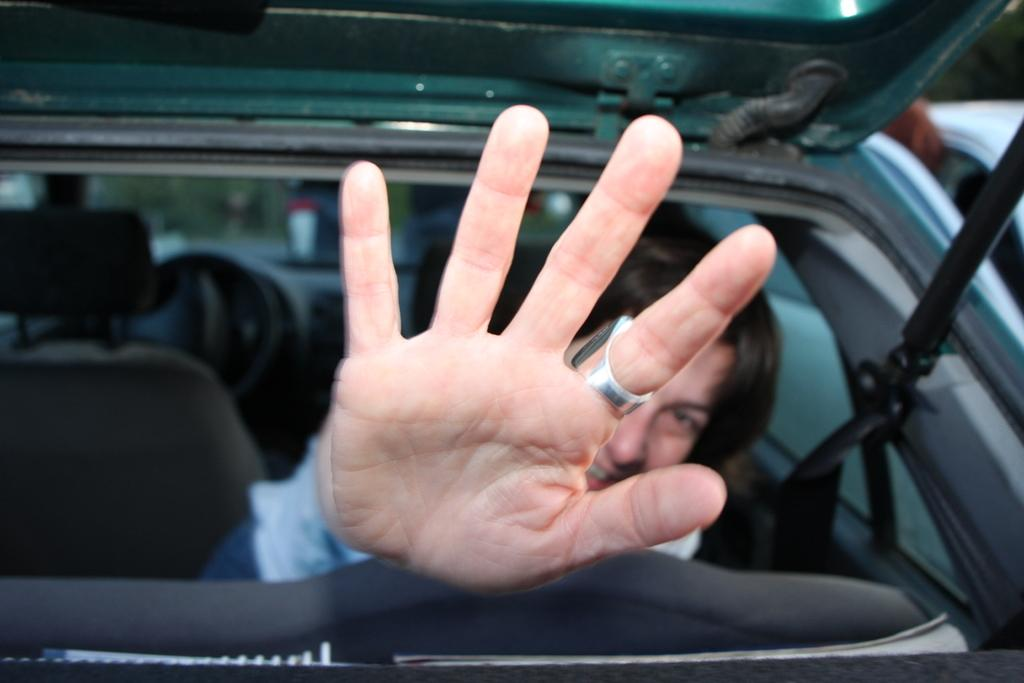What part of a person's body is visible in the image? A person's hand is visible in the image. Where is the person sitting in the image? The person is sitting in a car. What is the person doing with their hand in the image? The person has their hand outside the car. How is the background of the person depicted in the image? The background of the person is blurred. What type of bone can be seen in the image? There is no bone present in the image; it features a person's hand outside a car. How many cattle are visible in the image? There are no cattle present in the image. 